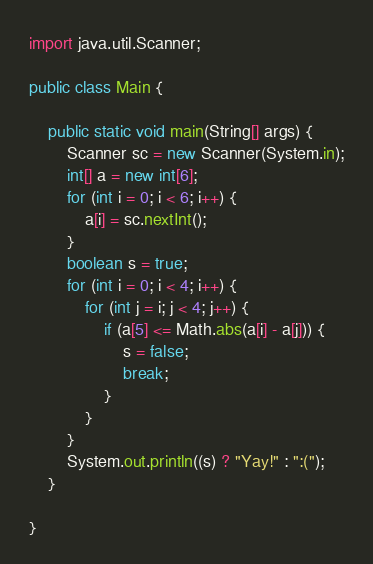Convert code to text. <code><loc_0><loc_0><loc_500><loc_500><_Java_>import java.util.Scanner;

public class Main {

	public static void main(String[] args) {
		Scanner sc = new Scanner(System.in);
		int[] a = new int[6];
		for (int i = 0; i < 6; i++) {
			a[i] = sc.nextInt();
		}
		boolean s = true;
		for (int i = 0; i < 4; i++) {
			for (int j = i; j < 4; j++) {
				if (a[5] <= Math.abs(a[i] - a[j])) {
					s = false;
					break;
				}
			}
		}
		System.out.println((s) ? "Yay!" : ":(");
	}

}
</code> 